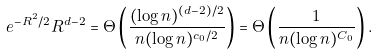Convert formula to latex. <formula><loc_0><loc_0><loc_500><loc_500>e ^ { - R ^ { 2 } / 2 } R ^ { d - 2 } = \Theta \left ( \frac { ( \log n ) ^ { ( d - 2 ) / 2 } } { n ( \log n ) ^ { c _ { 0 } / 2 } } \right ) = \Theta \left ( \frac { 1 } { n ( \log n ) ^ { C _ { 0 } } } \right ) .</formula> 